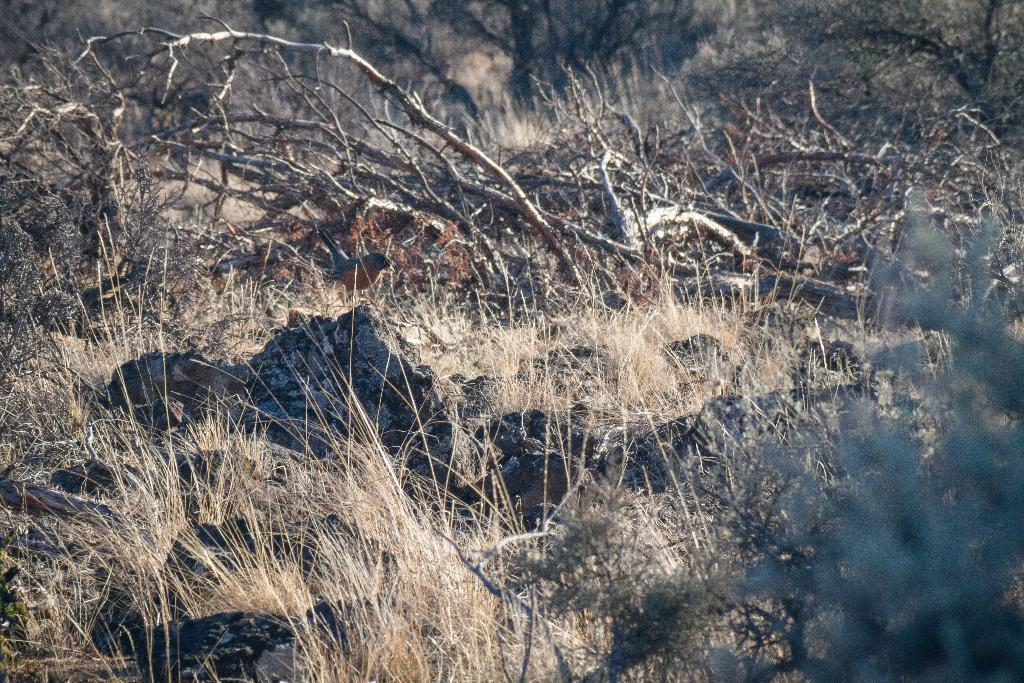What is the main subject in the center of the image? There is a rock in the center of the image. What type of vegetation can be seen in the image? There are dry trees in the image. What type of terrain is visible in the image? There is dry grassland in the image. What type of pancake is being served on the road in the image? There is no pancake or road present in the image; it features a rock, dry trees, and dry grassland. 